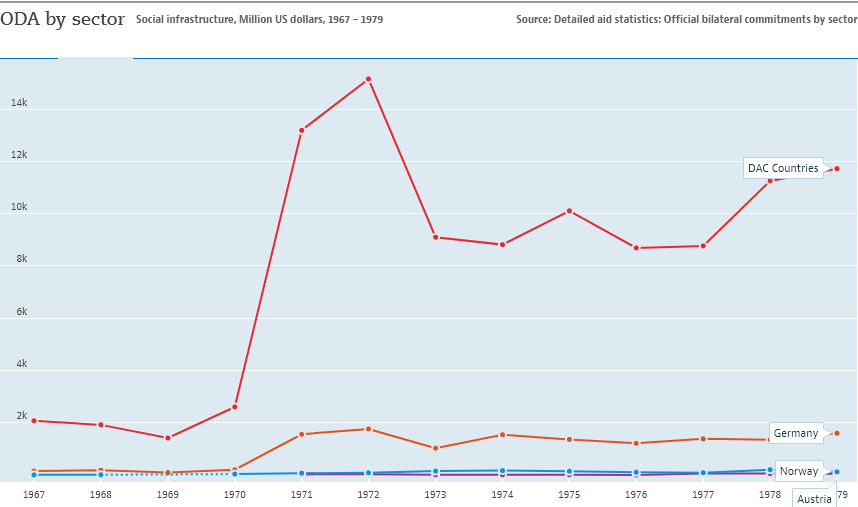Identify some key points in this picture. The color of the line representing Germany is orange. The sum of Germany, Norway, and Austria is not larger than the value of DAC countries in 1978. 